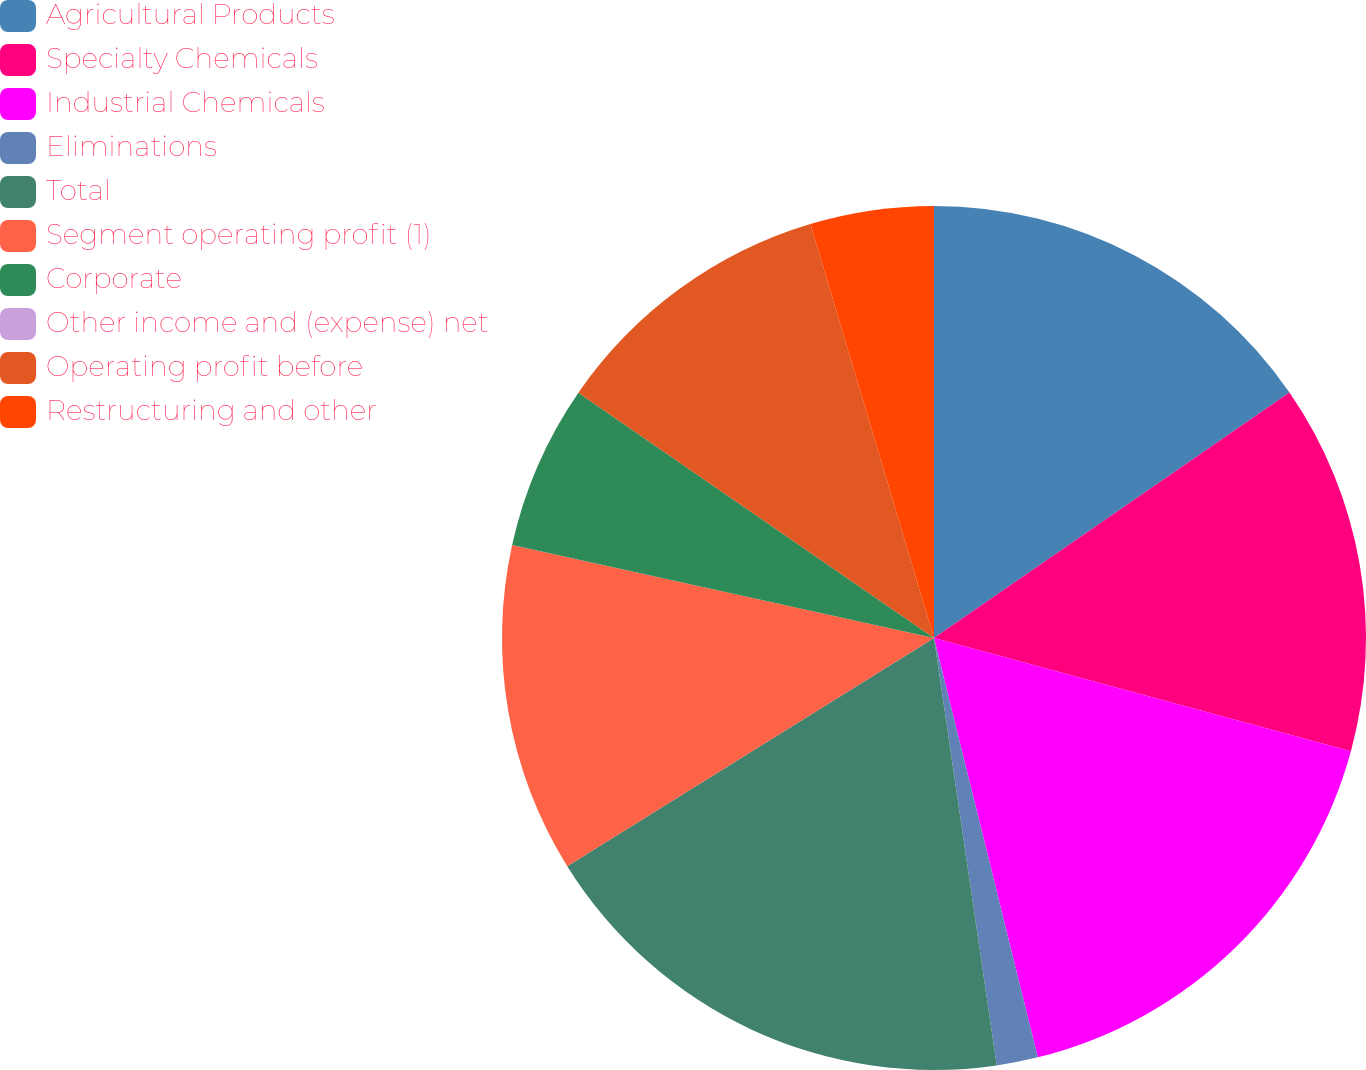Convert chart. <chart><loc_0><loc_0><loc_500><loc_500><pie_chart><fcel>Agricultural Products<fcel>Specialty Chemicals<fcel>Industrial Chemicals<fcel>Eliminations<fcel>Total<fcel>Segment operating profit (1)<fcel>Corporate<fcel>Other income and (expense) net<fcel>Operating profit before<fcel>Restructuring and other<nl><fcel>15.38%<fcel>13.84%<fcel>16.92%<fcel>1.54%<fcel>18.46%<fcel>12.31%<fcel>6.16%<fcel>0.0%<fcel>10.77%<fcel>4.62%<nl></chart> 